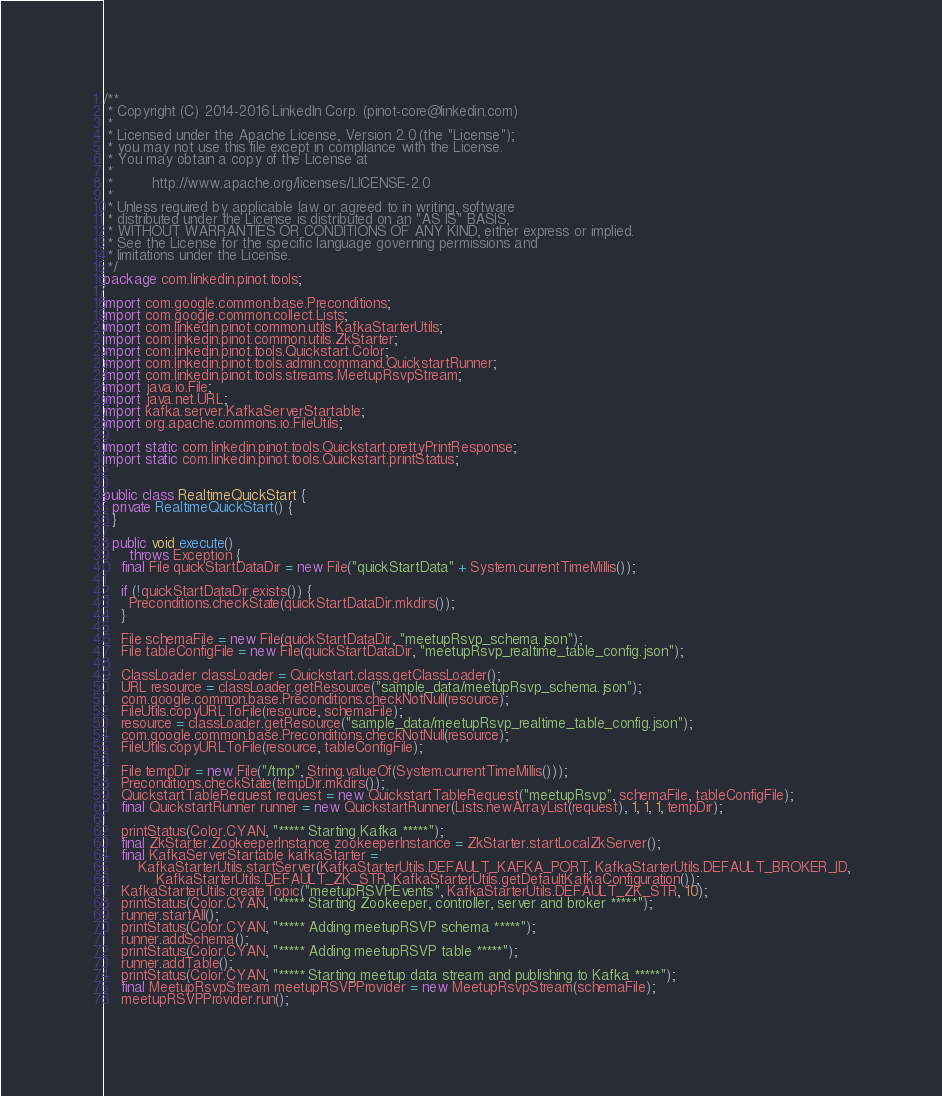Convert code to text. <code><loc_0><loc_0><loc_500><loc_500><_Java_>/**
 * Copyright (C) 2014-2016 LinkedIn Corp. (pinot-core@linkedin.com)
 *
 * Licensed under the Apache License, Version 2.0 (the "License");
 * you may not use this file except in compliance with the License.
 * You may obtain a copy of the License at
 *
 *         http://www.apache.org/licenses/LICENSE-2.0
 *
 * Unless required by applicable law or agreed to in writing, software
 * distributed under the License is distributed on an "AS IS" BASIS,
 * WITHOUT WARRANTIES OR CONDITIONS OF ANY KIND, either express or implied.
 * See the License for the specific language governing permissions and
 * limitations under the License.
 */
package com.linkedin.pinot.tools;

import com.google.common.base.Preconditions;
import com.google.common.collect.Lists;
import com.linkedin.pinot.common.utils.KafkaStarterUtils;
import com.linkedin.pinot.common.utils.ZkStarter;
import com.linkedin.pinot.tools.Quickstart.Color;
import com.linkedin.pinot.tools.admin.command.QuickstartRunner;
import com.linkedin.pinot.tools.streams.MeetupRsvpStream;
import java.io.File;
import java.net.URL;
import kafka.server.KafkaServerStartable;
import org.apache.commons.io.FileUtils;

import static com.linkedin.pinot.tools.Quickstart.prettyPrintResponse;
import static com.linkedin.pinot.tools.Quickstart.printStatus;


public class RealtimeQuickStart {
  private RealtimeQuickStart() {
  }

  public void execute()
      throws Exception {
    final File quickStartDataDir = new File("quickStartData" + System.currentTimeMillis());

    if (!quickStartDataDir.exists()) {
      Preconditions.checkState(quickStartDataDir.mkdirs());
    }

    File schemaFile = new File(quickStartDataDir, "meetupRsvp_schema.json");
    File tableConfigFile = new File(quickStartDataDir, "meetupRsvp_realtime_table_config.json");

    ClassLoader classLoader = Quickstart.class.getClassLoader();
    URL resource = classLoader.getResource("sample_data/meetupRsvp_schema.json");
    com.google.common.base.Preconditions.checkNotNull(resource);
    FileUtils.copyURLToFile(resource, schemaFile);
    resource = classLoader.getResource("sample_data/meetupRsvp_realtime_table_config.json");
    com.google.common.base.Preconditions.checkNotNull(resource);
    FileUtils.copyURLToFile(resource, tableConfigFile);

    File tempDir = new File("/tmp", String.valueOf(System.currentTimeMillis()));
    Preconditions.checkState(tempDir.mkdirs());
    QuickstartTableRequest request = new QuickstartTableRequest("meetupRsvp", schemaFile, tableConfigFile);
    final QuickstartRunner runner = new QuickstartRunner(Lists.newArrayList(request), 1, 1, 1, tempDir);

    printStatus(Color.CYAN, "***** Starting Kafka *****");
    final ZkStarter.ZookeeperInstance zookeeperInstance = ZkStarter.startLocalZkServer();
    final KafkaServerStartable kafkaStarter =
        KafkaStarterUtils.startServer(KafkaStarterUtils.DEFAULT_KAFKA_PORT, KafkaStarterUtils.DEFAULT_BROKER_ID,
            KafkaStarterUtils.DEFAULT_ZK_STR, KafkaStarterUtils.getDefaultKafkaConfiguration());
    KafkaStarterUtils.createTopic("meetupRSVPEvents", KafkaStarterUtils.DEFAULT_ZK_STR, 10);
    printStatus(Color.CYAN, "***** Starting Zookeeper, controller, server and broker *****");
    runner.startAll();
    printStatus(Color.CYAN, "***** Adding meetupRSVP schema *****");
    runner.addSchema();
    printStatus(Color.CYAN, "***** Adding meetupRSVP table *****");
    runner.addTable();
    printStatus(Color.CYAN, "***** Starting meetup data stream and publishing to Kafka *****");
    final MeetupRsvpStream meetupRSVPProvider = new MeetupRsvpStream(schemaFile);
    meetupRSVPProvider.run();</code> 